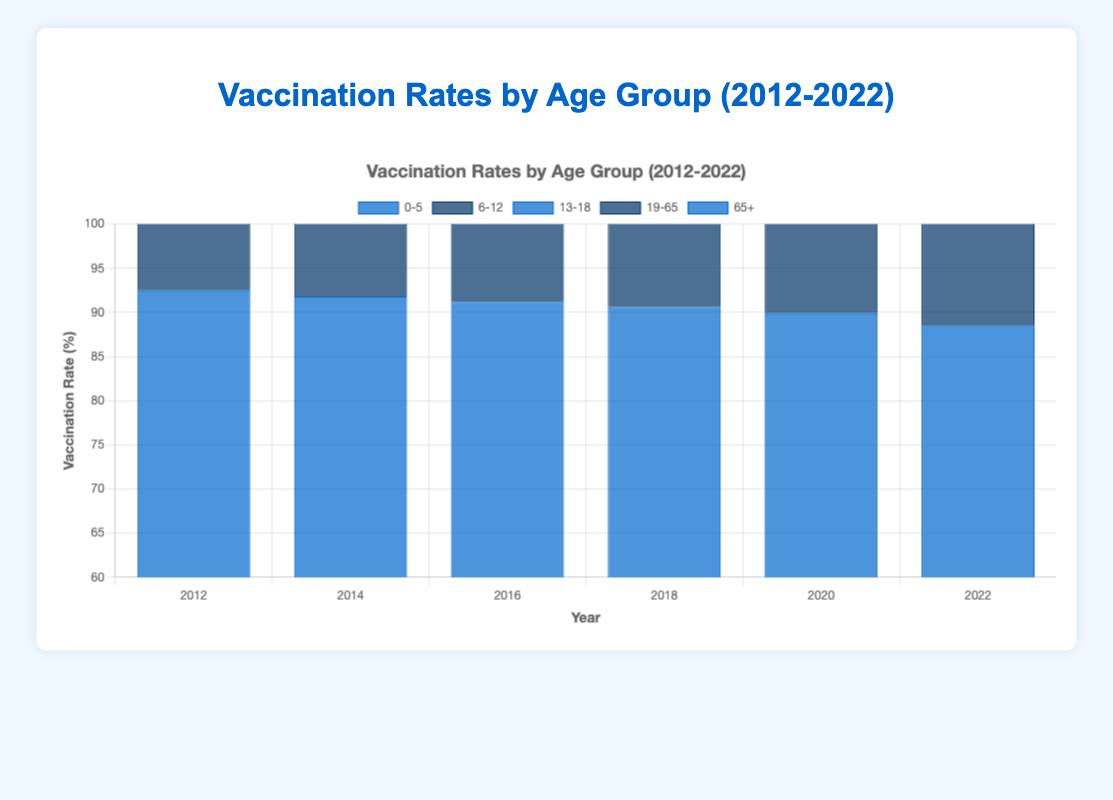Which age group had the highest vaccination rate in 2022? By looking at the bars representing the different age groups in 2022, the highest bar will indicate the highest vaccination rate. The AgeGroup "65+" has the highest bar in 2022.
Answer: 65+ What has been the general trend of the vaccination rate for the 0-5 age group from 2012 to 2022? Starting from the leftmost bar for AgeGroup "0-5" in 2012 and moving right until 2022, the bars have been gradually decreasing in height. This shows a general declining trend in the vaccination rate over the past decade.
Answer: Decreasing Compare the vaccination rate of the 6-12 age group in 2012 and 2022. Which year had a higher rate? By comparing the height of the bar for AgeGroup "6-12" in 2012 and 2022, the bar in 2012 is higher.
Answer: 2012 Which age group showed an increasing vaccination rate trend from 2012 to 2022? By following each age group's bars from 2012 to 2022, the AgeGroup "65+" shows increasing bar heights consistently, indicating an increasing trend.
Answer: 65+ What is the largest difference in vaccination rates between any two consecutive years for the 13-18 age group? Subtract the vaccination rates year-over-year for the AgeGroup "13-18": 87.0-86.4=0.6 (2012-2014), 86.4-85.7=0.7 (2014-2016), 85.7-85.1=0.6 (2016-2018), 85.1-84.5=0.6 (2018-2020), 84.5-83.8=0.7 (2020-2022). The largest difference is 0.7.
Answer: 0.7 In which year did the 0-5 age group experience the highest vaccination rate? By examining the bars of AgeGroup "0-5" from 2012 to 2022, the highest bar at 92.5% appears in the year 2012.
Answer: 2012 Calculate the average vaccination rate for the 19-65 age group from 2012 to 2022. Add the vaccination rates for AgeGroup "19-65": 68.0+67.5+67.0+66.5+65.9+65.4=400.3. Divide this sum by the number of years (6): 400.3/6=66.72.
Answer: 66.72 Which age group experienced the smallest percentage decrease in vaccination rate from 2012 to 2022? Calculate the difference in vaccination rates from 2012 to 2022 for each group: 0-5 (92.5-88.5=4.0), 6-12 (95.0-91.7=3.3), 13-18 (87.0-83.8=3.2), 19-65 (68.0-65.4=2.6), 65+ (78.8-75.3=-3.5). The smallest decrease is for AgeGroup "19-65".
Answer: 19-65 What is the median vaccination rate for all age groups in 2022? List the 2022 rates: 88.5, 91.7, 83.8, 65.4, 78.8. Sort them: 65.4, 78.8, 83.8, 88.5, 91.7. The median is the middle number: 83.8.
Answer: 83.8 Which age group had the most significant decline in vaccination rate over the decade? Calculate the difference in vaccination rates from 2012 to 2022 for each group: 0-5 (92.5-88.5=4.0), 6-12 (95.0-91.7=3.3), 13-18 (87.0-83.8=3.2), 19-65 (68.0-65.4=2.6), 65+ (78.8-75.3=-3.5). The largest decrease is for AgeGroup "0-5".
Answer: 0-5 